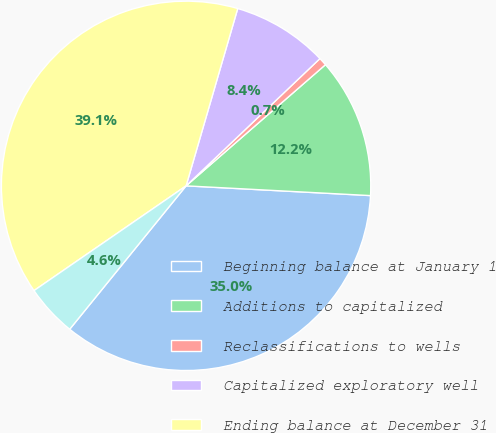Convert chart to OTSL. <chart><loc_0><loc_0><loc_500><loc_500><pie_chart><fcel>Beginning balance at January 1<fcel>Additions to capitalized<fcel>Reclassifications to wells<fcel>Capitalized exploratory well<fcel>Ending balance at December 31<fcel>Number of wells at end of year<nl><fcel>35.01%<fcel>12.23%<fcel>0.71%<fcel>8.39%<fcel>39.11%<fcel>4.55%<nl></chart> 